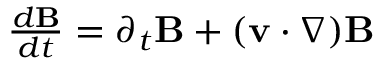Convert formula to latex. <formula><loc_0><loc_0><loc_500><loc_500>\begin{array} { r } { { \frac { d { B } } { d t } } = \partial _ { t } { B } + ( { v } \cdot \nabla ) { B } } \end{array}</formula> 